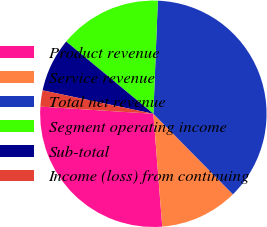Convert chart. <chart><loc_0><loc_0><loc_500><loc_500><pie_chart><fcel>Product revenue<fcel>Service revenue<fcel>Total net revenue<fcel>Segment operating income<fcel>Sub-total<fcel>Income (loss) from continuing<nl><fcel>27.26%<fcel>11.15%<fcel>36.97%<fcel>14.62%<fcel>7.69%<fcel>2.31%<nl></chart> 